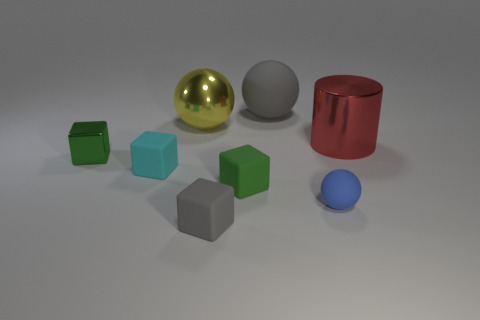Subtract all cylinders. How many objects are left? 7 Add 6 large blue balls. How many large blue balls exist? 6 Subtract 0 cyan cylinders. How many objects are left? 8 Subtract all yellow cubes. Subtract all rubber cubes. How many objects are left? 5 Add 1 small rubber blocks. How many small rubber blocks are left? 4 